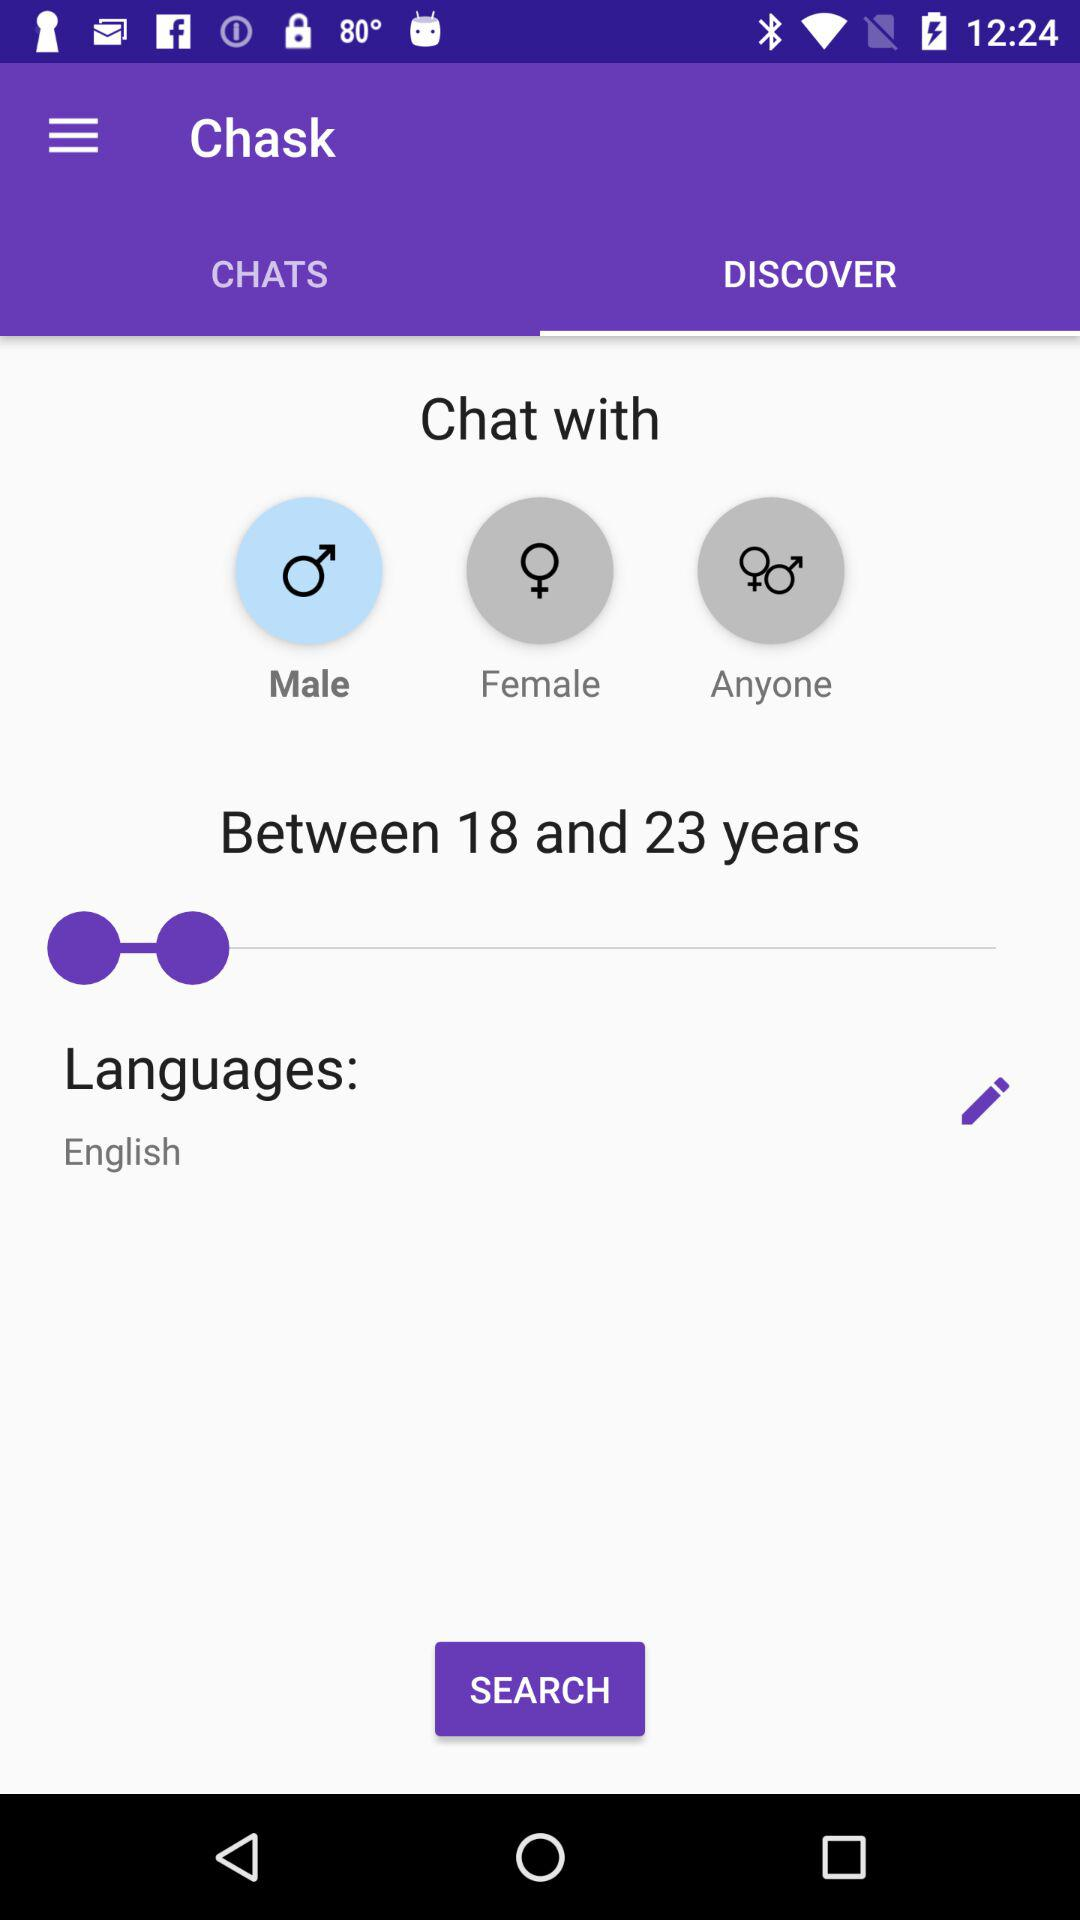What gender is selected? The selected gender is "Male". 